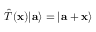Convert formula to latex. <formula><loc_0><loc_0><loc_500><loc_500>{ \hat { T } } ( x ) | a \rangle = | a + x \rangle</formula> 